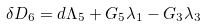Convert formula to latex. <formula><loc_0><loc_0><loc_500><loc_500>\delta D _ { 6 } = d \Lambda _ { 5 } + G _ { 5 } \lambda _ { 1 } - G _ { 3 } \lambda _ { 3 }</formula> 